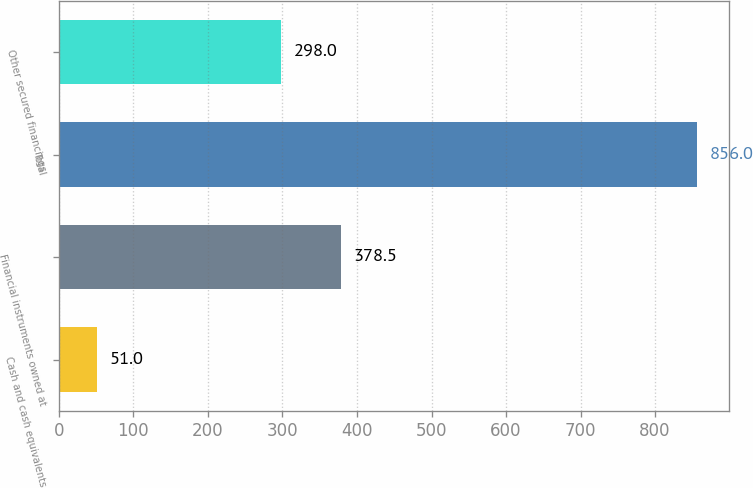Convert chart to OTSL. <chart><loc_0><loc_0><loc_500><loc_500><bar_chart><fcel>Cash and cash equivalents<fcel>Financial instruments owned at<fcel>Total<fcel>Other secured financings<nl><fcel>51<fcel>378.5<fcel>856<fcel>298<nl></chart> 